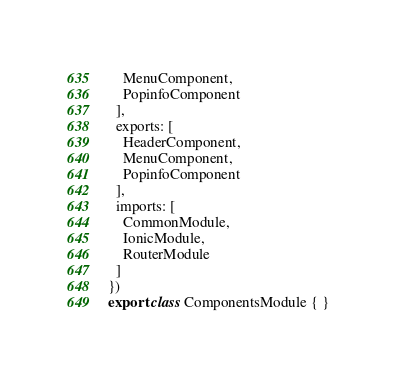<code> <loc_0><loc_0><loc_500><loc_500><_TypeScript_>    MenuComponent,
    PopinfoComponent
  ],
  exports: [
    HeaderComponent,
    MenuComponent,
    PopinfoComponent
  ],
  imports: [
    CommonModule,
    IonicModule,
    RouterModule
  ]
})
export class ComponentsModule { }
</code> 